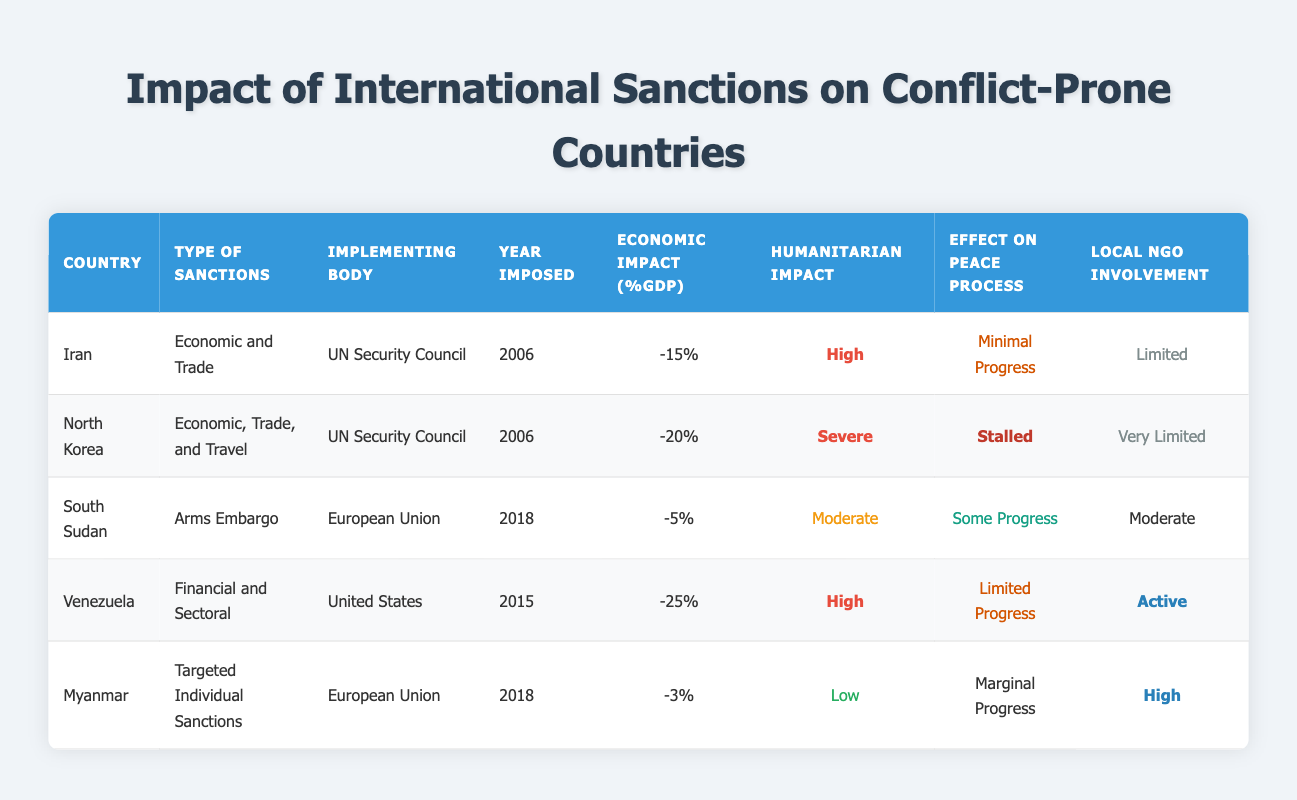What type of sanctions were imposed on Iran? The table indicates that Iran is under "Economic and Trade" sanctions, which are listed in the second column of the row corresponding to Iran.
Answer: Economic and Trade What was the year when sanctions were imposed on Venezuela? The table shows that the sanctions on Venezuela were imposed in the year 2015, which is stated in the fourth column of the corresponding row.
Answer: 2015 Which country experienced a severe humanitarian impact from international sanctions? By reviewing the table, North Korea is noted to have a "Severe" humanitarian impact, as indicated in the fifth column of its row.
Answer: North Korea How many countries in the table had a humanitarian impact classified as high? The table lists Iran and Venezuela having a "High" humanitarian impact. Therefore, by counting the rows with this classification, we find there are two countries.
Answer: 2 What is the average economic impact (%GDP) of the sanctions imposed on the five countries listed? First, sum the economic impacts: -15 + -20 + -5 + -25 + -3 = -68. Then divide by the number of countries (5) to find the average: -68/5 = -13.6.
Answer: -13.6 Did any country show "Stalled" progress in the peace process? By analyzing the table, North Korea is the only country that shows "Stalled" in the effect on the peace process, appearing in the seventh column.
Answer: Yes Which country with sanctions had the least economic impact (%GDP)? The least economic impact is recorded for Myanmar with -3% GDP impact, as seen in the fifth column of its row in the table.
Answer: Myanmar Is there a correlation between the type of sanctions imposed and the local NGO involvement in these countries? Upon examining the table, while countries like Venezuela and Myanmar have different types of sanctions, both exhibit either "Active" or "High" local NGO involvement. However, without further analysis, no conclusive correlation can be determined explicitly from the table alone.
Answer: No Which country had the greatest involvement from local NGOs? The table indicates that Myanmar had "High" local NGO involvement, as listed in the eighth column of its row, which is the highest classification presented.
Answer: Myanmar 